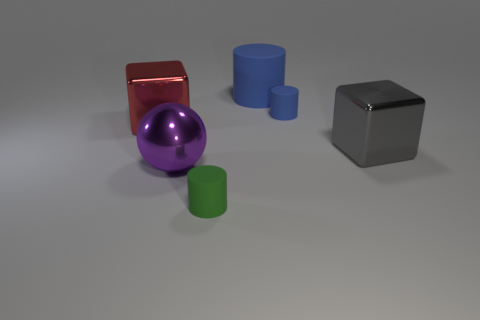How many other things are made of the same material as the big gray thing?
Offer a terse response. 2. There is a large shiny object that is in front of the metallic thing right of the big cylinder; what is its shape?
Ensure brevity in your answer.  Sphere. What size is the cube that is right of the large blue thing?
Offer a very short reply. Large. Do the large cylinder and the purple thing have the same material?
Your answer should be very brief. No. What is the shape of the red thing that is the same material as the purple sphere?
Offer a terse response. Cube. Is there anything else of the same color as the big rubber thing?
Your response must be concise. Yes. What color is the big thing that is behind the tiny blue thing?
Ensure brevity in your answer.  Blue. There is a large cube that is left of the small blue object; does it have the same color as the big cylinder?
Keep it short and to the point. No. What is the material of the big blue object that is the same shape as the tiny blue matte thing?
Keep it short and to the point. Rubber. How many red things have the same size as the gray metallic cube?
Keep it short and to the point. 1. 